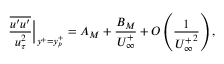<formula> <loc_0><loc_0><loc_500><loc_500>\frac { \overline { { u ^ { \prime } u ^ { \prime } } } } { u _ { \tau } ^ { 2 } } \Big | _ { y ^ { + } = y _ { p } ^ { + } } = A _ { M } + \frac { B _ { M } } { U _ { \infty } ^ { + } } + O \left ( \frac { 1 } { { U _ { \infty } ^ { + } } ^ { 2 } } \right ) ,</formula> 